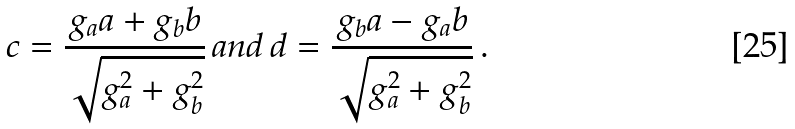<formula> <loc_0><loc_0><loc_500><loc_500>c = \frac { g _ { a } a + g _ { b } b } { \sqrt { g _ { a } ^ { 2 } + g _ { b } ^ { 2 } } } \, a n d \, d = \frac { g _ { b } a - g _ { a } b } { \sqrt { g _ { a } ^ { 2 } + g _ { b } ^ { 2 } } } \, .</formula> 